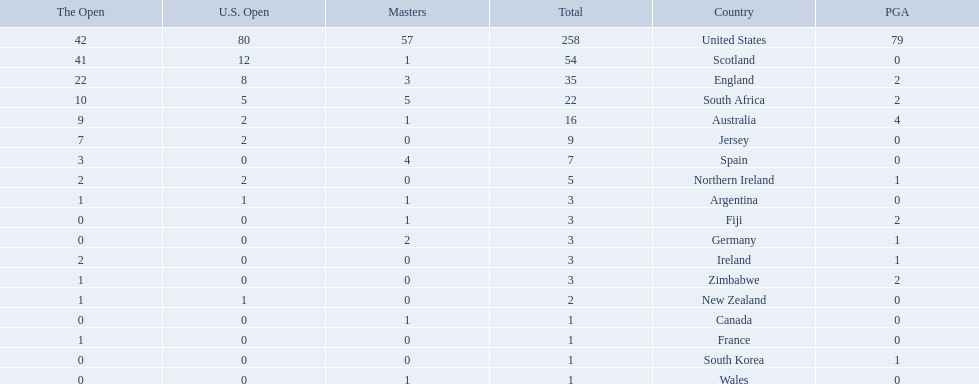What are all the countries? United States, Scotland, England, South Africa, Australia, Jersey, Spain, Northern Ireland, Argentina, Fiji, Germany, Ireland, Zimbabwe, New Zealand, Canada, France, South Korea, Wales. Which ones are located in africa? South Africa, Zimbabwe. Of those, which has the least champion golfers? Zimbabwe. 